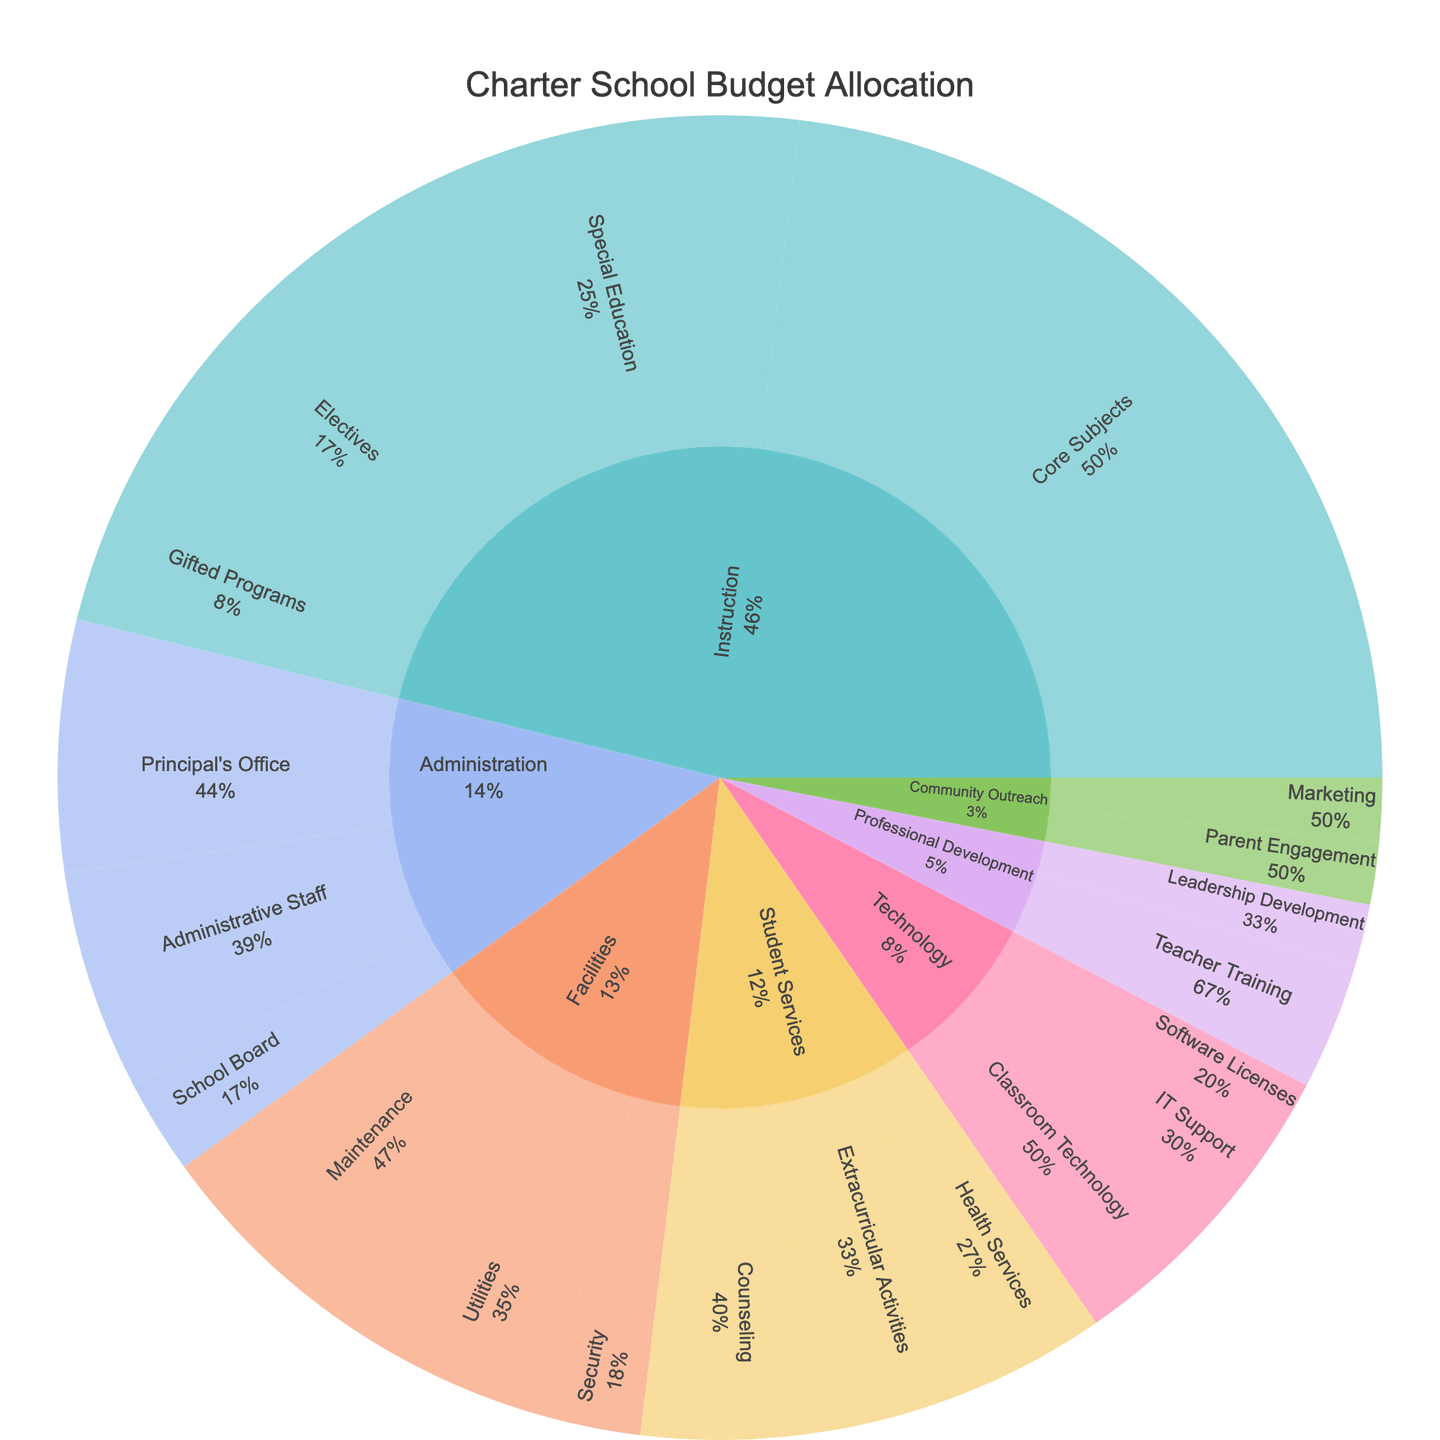What is the total budget allocated to Instruction? The sunburst chart indicates the budget allocation for each subcategory under Instruction. Add the values for Core Subjects (30), Special Education (15), Electives (10), and Gifted Programs (5). Thus, the total is 30 + 15 + 10 + 5 = 60.
Answer: 60k Which category receives the largest budget allocation? By looking at the largest section in the sunburst chart, Instruction has the highest budget allocation.
Answer: Instruction Which subcategory under Student Services is allocated the least budget? Under Student Services, the sunburst sections Counseling (6), Health Services (4), and Extracurricular Activities (5) are visible. Health Services has the smallest allocation.
Answer: Health Services How does the budget for Classroom Technology compare to IT Support? To compare these subcategories, look at their respective segments in the Technology category. Classroom Technology is allocated 5k, while IT Support is allocated 3k. Classroom Technology has a larger budget.
Answer: Classroom Technology > IT Support What percentage of the budget is allocated to Facilities? By summing the values for Maintenance (8), Utilities (6), and Security (3), the total for Facilities is 8 + 6 + 3 = 17k. To find the percentage, divide 17k by the total school budget (sum all values = 100) and convert to a percentage: (17/100) * 100 = 17%.
Answer: 17% What is the combined budget for Professional Development and Community Outreach? By adding up the values for Professional Development (Teacher Training: 4, Leadership Development: 2) and Community Outreach (Parent Engagement: 2, Marketing: 2), the total is (4 + 2 + 2 + 2) = 10.
Answer: 10k Is the budget for Principal's Office higher or lower than Administrative Staff? Look at the sunburst sections under Administration. Principal's Office is allocated 8k, while Administrative Staff is allocated 7k. Principal's Office has a higher budget.
Answer: Principal's Office > Administrative Staff Which subcategory under Instruction has the smallest budget allocation? Under Instruction, the sunburst sections show Core Subjects (30), Special Education (15), Electives (10), and Gifted Programs (5). Gifted Programs has the smallest allocation.
Answer: Gifted Programs What is the total budget for the Administration category? Adding the values for Principal's Office (8), Administrative Staff (7), and School Board (3) gives the total for Administration: 8 + 7 + 3 = 18.
Answer: 18k Which category has the second largest budget allocation after Instruction? By comparing the values, Facilities has the next largest section after Instruction.
Answer: Facilities 